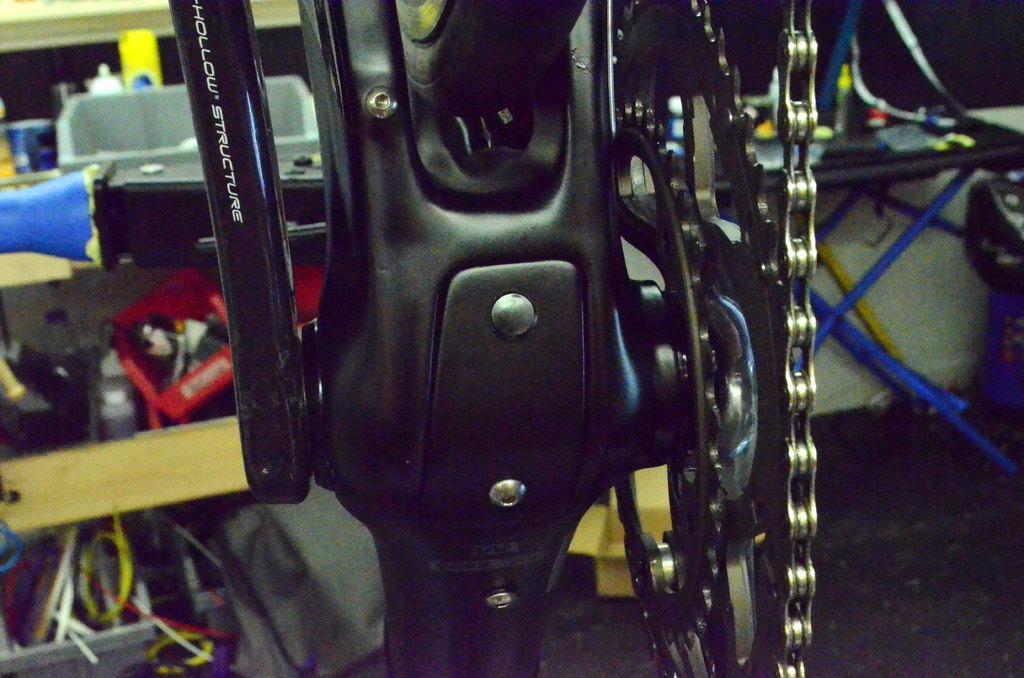Describe this image in one or two sentences. In this image I can see a bicycle chain, table, wires, wall and a pillar. This image is taken may be in a showroom. 